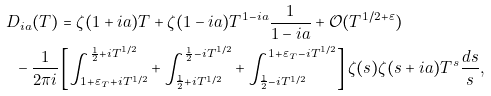Convert formula to latex. <formula><loc_0><loc_0><loc_500><loc_500>D _ { i a } ( T ) & = \zeta ( 1 + { i a } ) T + \zeta ( 1 - { i a } ) T ^ { 1 - { i a } } \frac { 1 } { 1 - { i a } } + \mathcal { O } ( T ^ { 1 / 2 + \varepsilon } ) \\ - \, \frac { 1 } { 2 \pi i } & \left [ \int _ { 1 + \varepsilon _ { T } + i T ^ { 1 / 2 } } ^ { \frac { 1 } { 2 } + i T ^ { 1 / 2 } } + \int _ { \frac { 1 } { 2 } + i T ^ { 1 / 2 } } ^ { \frac { 1 } { 2 } - i T ^ { 1 / 2 } } + \int _ { \frac { 1 } { 2 } - i T ^ { 1 / 2 } } ^ { 1 + \varepsilon _ { T } - i T ^ { 1 / 2 } } \right ] \zeta ( s ) \zeta ( s + { i a } ) T ^ { s } \frac { d s } { s } ,</formula> 